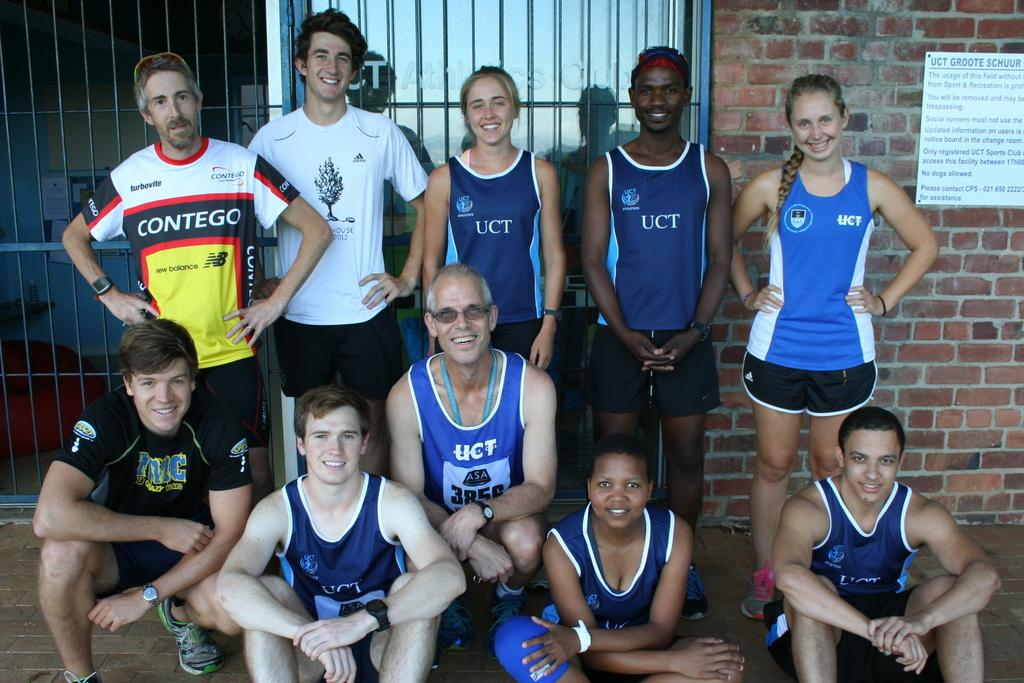<image>
Create a compact narrative representing the image presented. a shirt that has the letters uct on it 